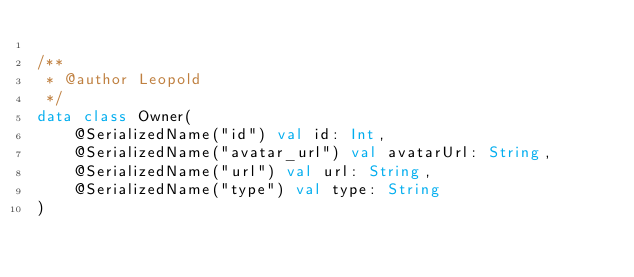Convert code to text. <code><loc_0><loc_0><loc_500><loc_500><_Kotlin_>
/**
 * @author Leopold
 */
data class Owner(
    @SerializedName("id") val id: Int,
    @SerializedName("avatar_url") val avatarUrl: String,
    @SerializedName("url") val url: String,
    @SerializedName("type") val type: String
)</code> 